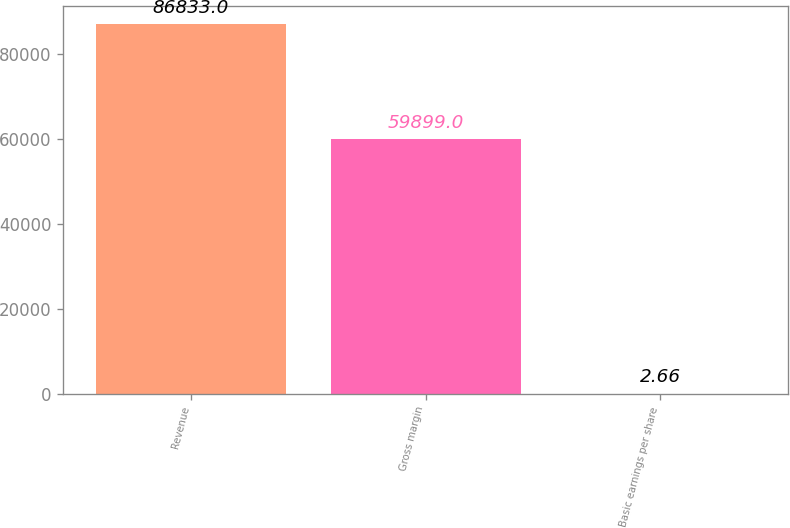Convert chart to OTSL. <chart><loc_0><loc_0><loc_500><loc_500><bar_chart><fcel>Revenue<fcel>Gross margin<fcel>Basic earnings per share<nl><fcel>86833<fcel>59899<fcel>2.66<nl></chart> 